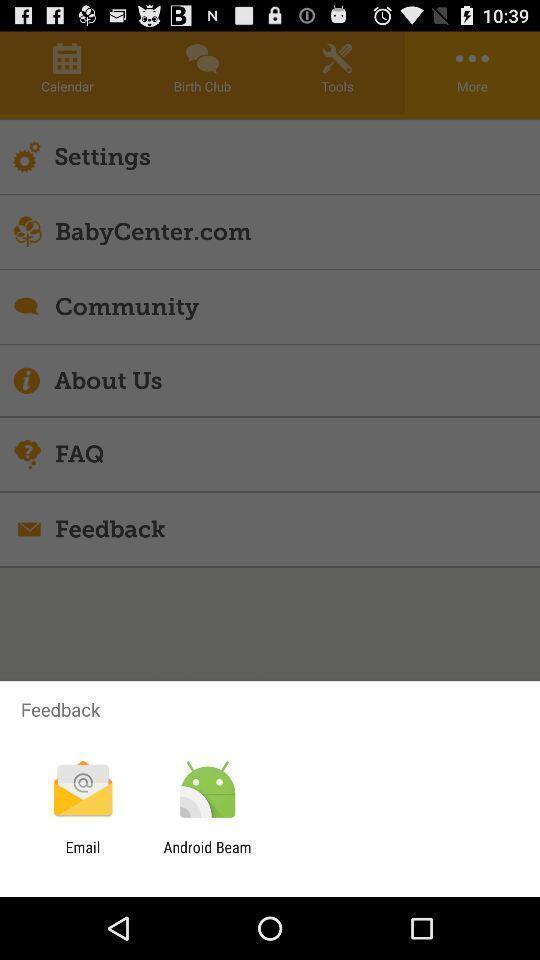What details can you identify in this image? Pop-up showing different applications to give. 